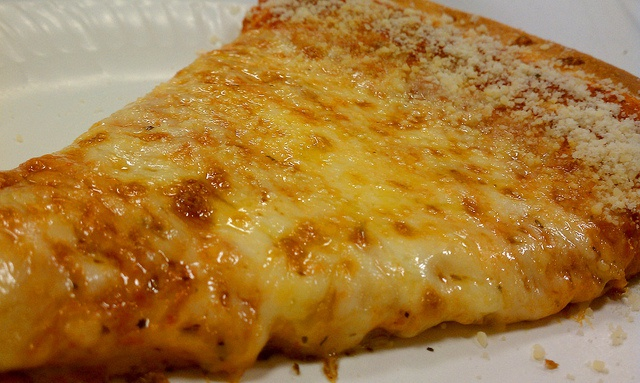Describe the objects in this image and their specific colors. I can see a pizza in olive, darkgray, orange, and tan tones in this image. 